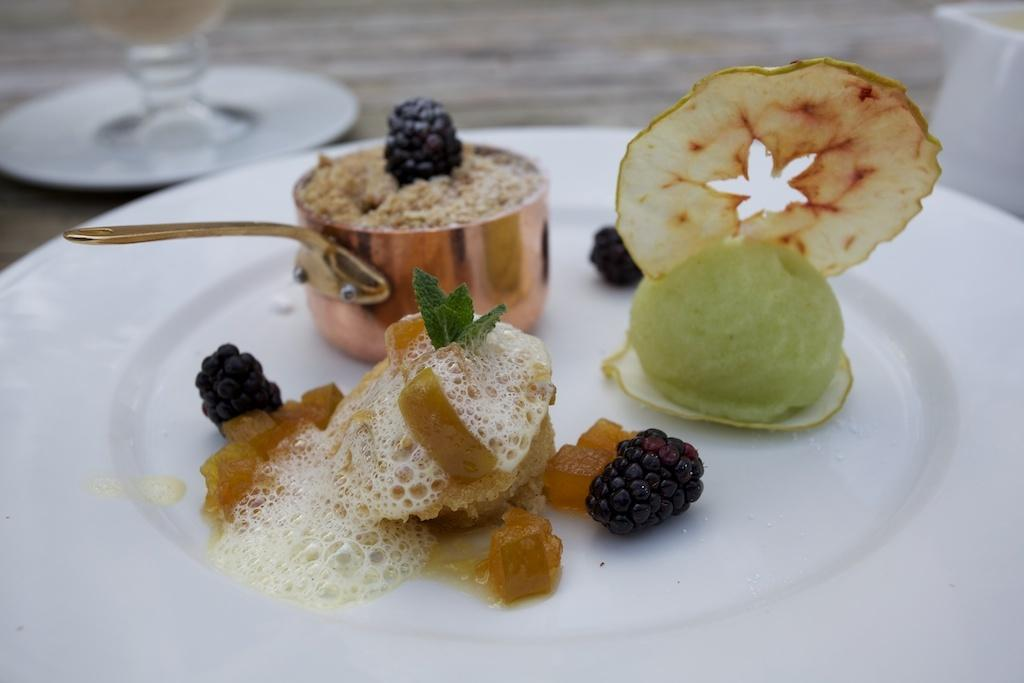What types of food items can be seen in the image? There are food items in the image, but their specific types cannot be determined from the provided facts. What colors are the food items in the image? The food items are in green, cream, brown, and black colors. What color is the plate that holds the food items? The plate is in white color. How many boats are visible in the image? There are no boats present in the image. What type of ear is shown in the image? There is no ear present in the image. 